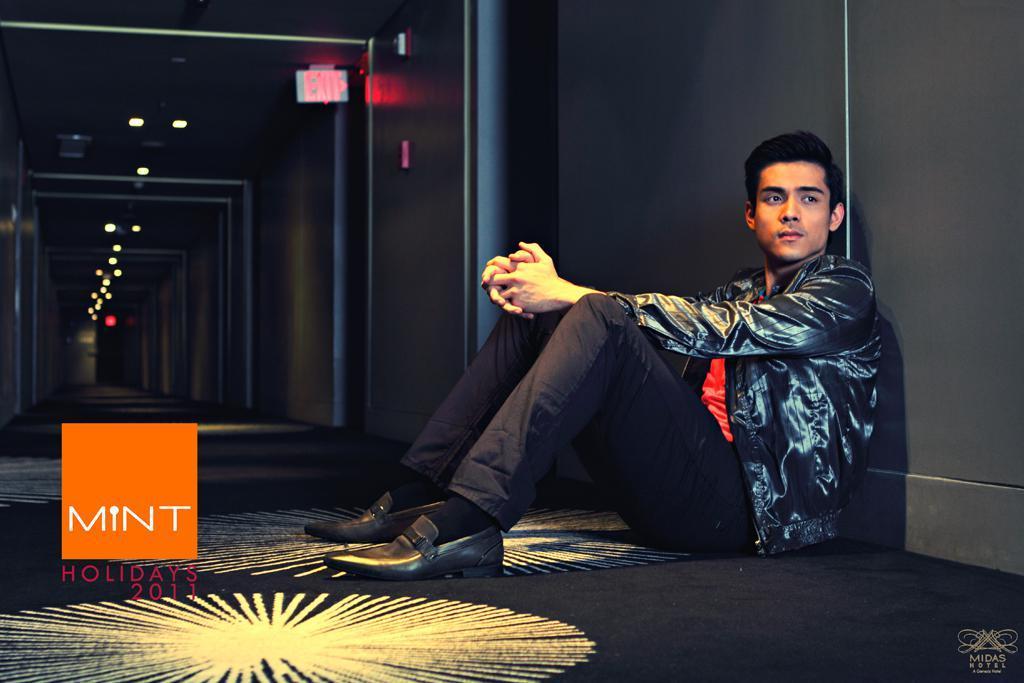Describe this image in one or two sentences. In the image we can see a man wearing clothes, shoes, socks and the man is sitting. Here we can see floor, wall and lights. There is an instruction board and on the bottom left we can see the watermark. 